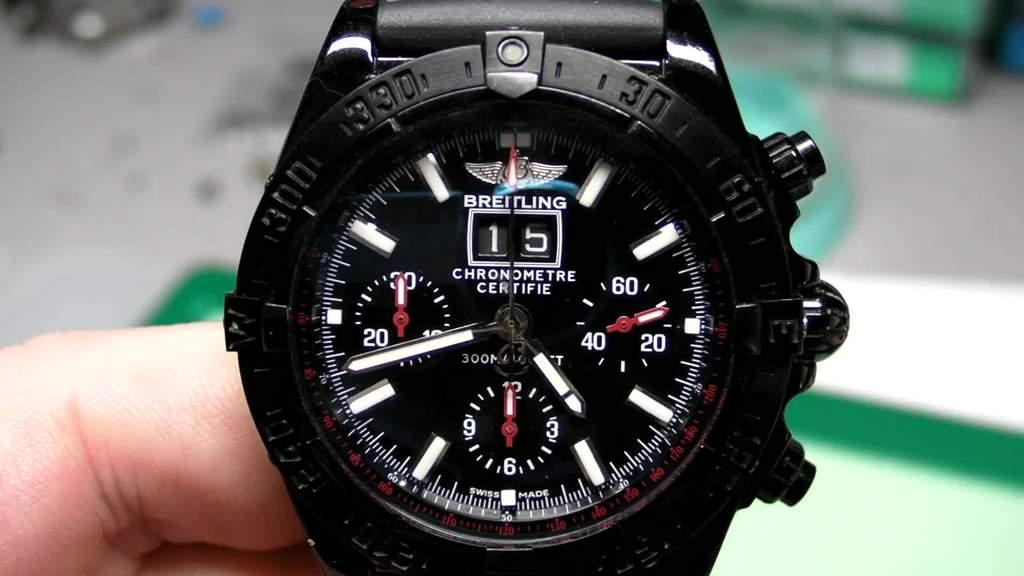<image>
Provide a brief description of the given image. A hand is holding a black Breitling watch. 